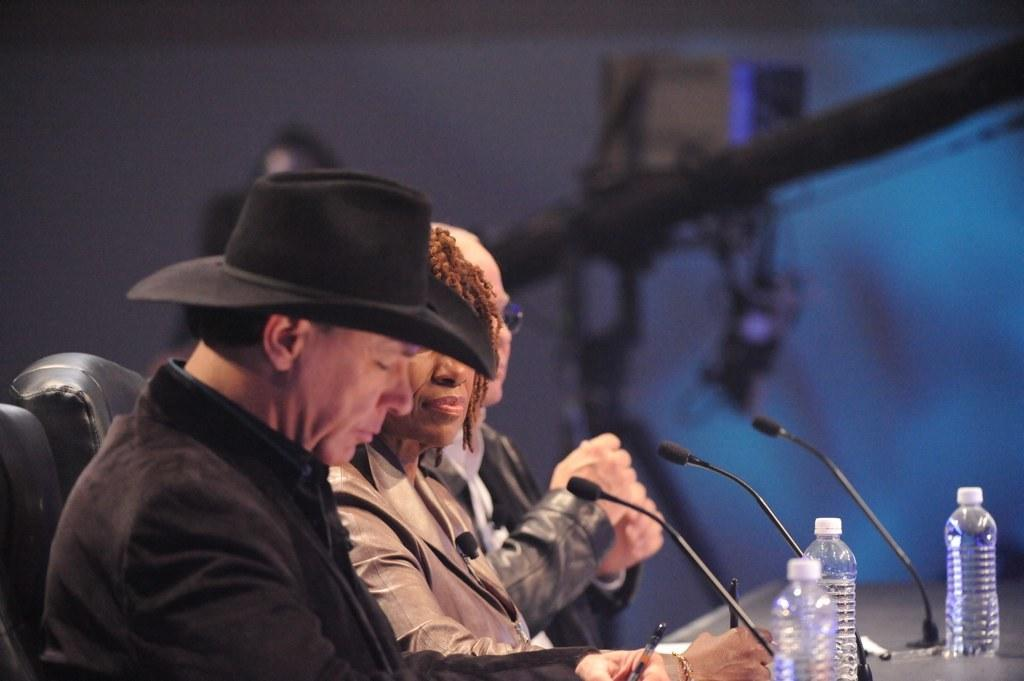How many people are sitting on chairs in the image? There are three people sitting on chairs on the left side of the image. What can be found on the table in the image? There are water bottles and microphones on the table. What type of jelly is being used to hold the microphones in place in the image? There is no jelly present in the image, and the microphones are not being held in place by any jelly. 